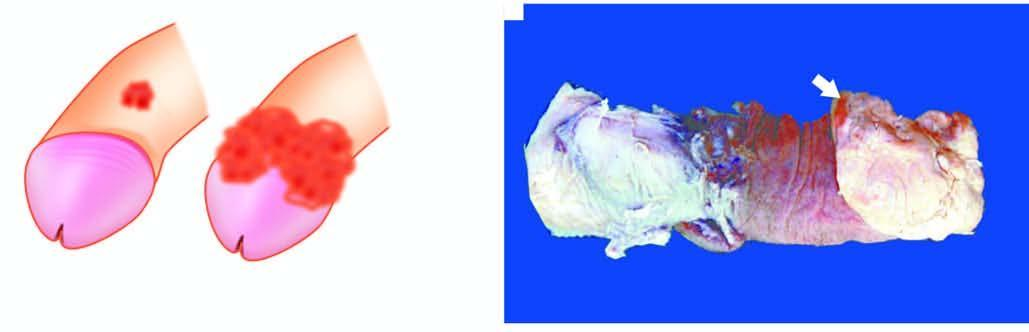does amputated specimen of the penis show a cauliflower growth on the coronal sulcus?
Answer the question using a single word or phrase. Yes 